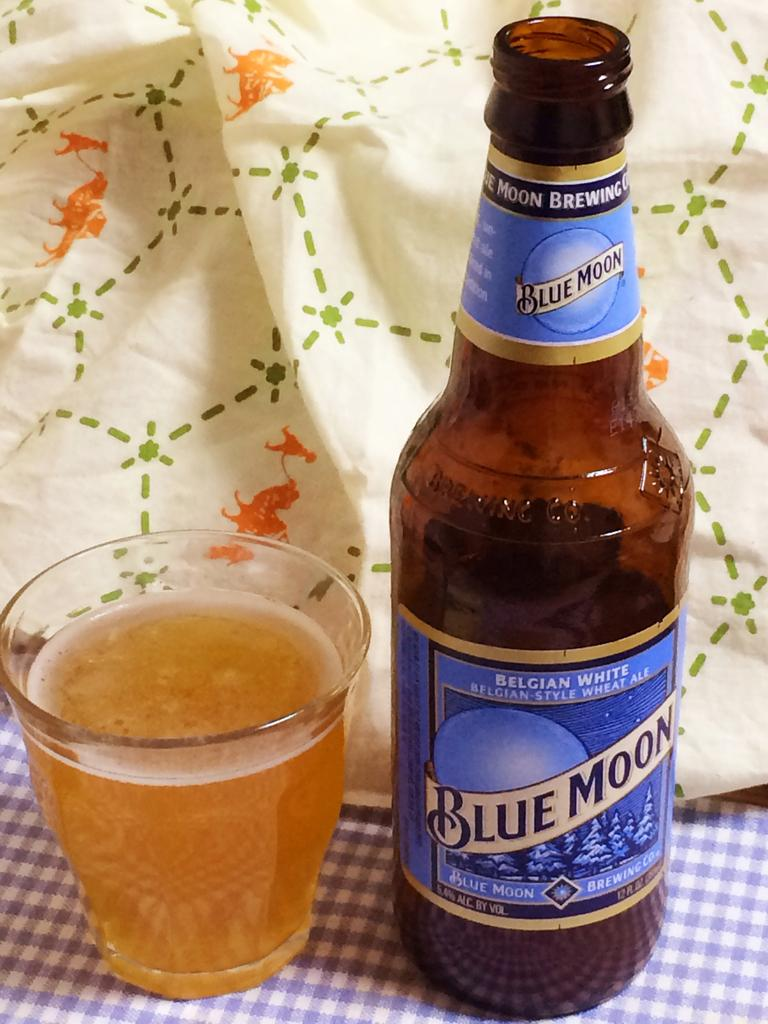Provide a one-sentence caption for the provided image. A bottle of Blue Moon beer on a checkered table next to a small glass. 